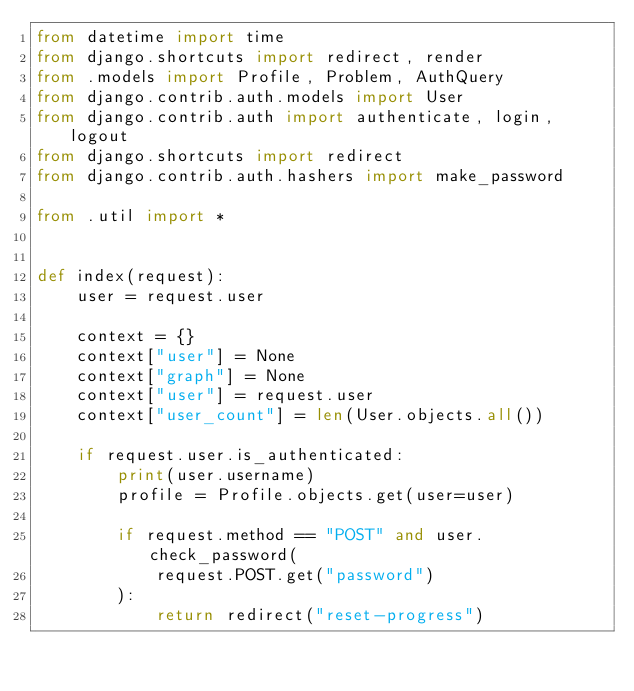Convert code to text. <code><loc_0><loc_0><loc_500><loc_500><_Python_>from datetime import time
from django.shortcuts import redirect, render
from .models import Profile, Problem, AuthQuery
from django.contrib.auth.models import User
from django.contrib.auth import authenticate, login, logout
from django.shortcuts import redirect
from django.contrib.auth.hashers import make_password

from .util import *


def index(request):
    user = request.user

    context = {}
    context["user"] = None
    context["graph"] = None
    context["user"] = request.user
    context["user_count"] = len(User.objects.all())

    if request.user.is_authenticated:
        print(user.username)
        profile = Profile.objects.get(user=user)

        if request.method == "POST" and user.check_password(
            request.POST.get("password")
        ):
            return redirect("reset-progress")
</code> 